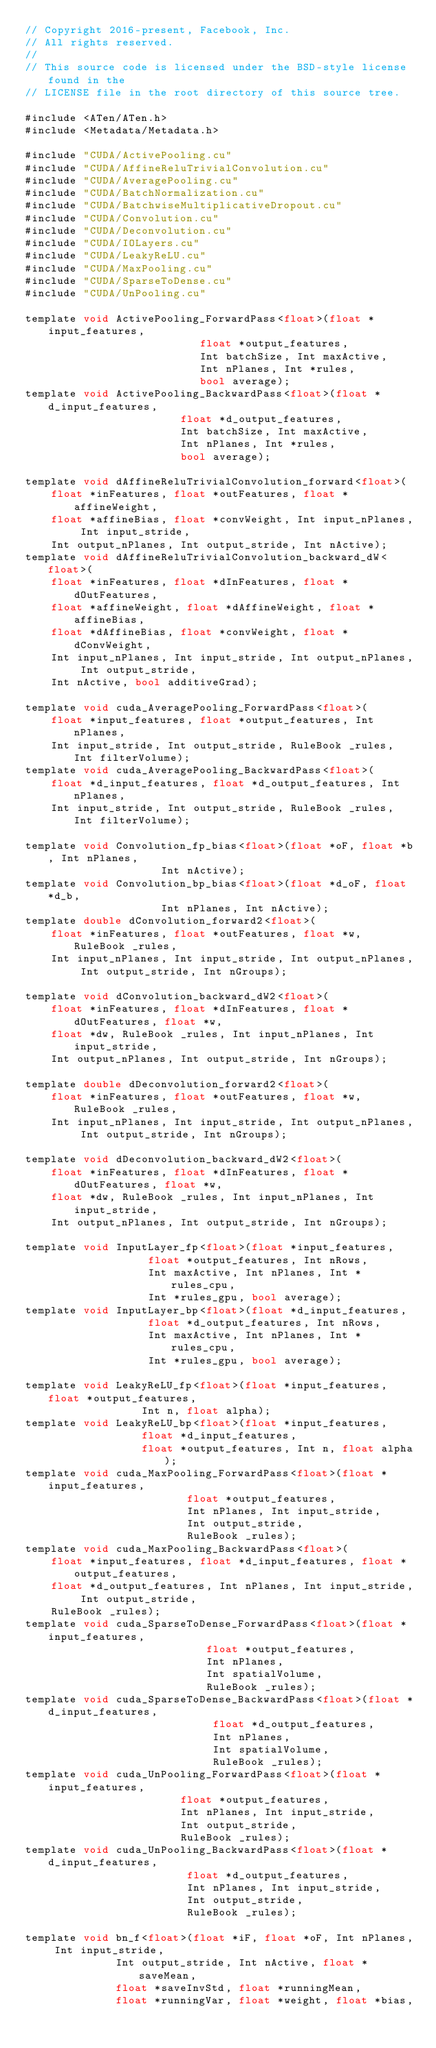Convert code to text. <code><loc_0><loc_0><loc_500><loc_500><_Cuda_>// Copyright 2016-present, Facebook, Inc.
// All rights reserved.
//
// This source code is licensed under the BSD-style license found in the
// LICENSE file in the root directory of this source tree.

#include <ATen/ATen.h>
#include <Metadata/Metadata.h>

#include "CUDA/ActivePooling.cu"
#include "CUDA/AffineReluTrivialConvolution.cu"
#include "CUDA/AveragePooling.cu"
#include "CUDA/BatchNormalization.cu"
#include "CUDA/BatchwiseMultiplicativeDropout.cu"
#include "CUDA/Convolution.cu"
#include "CUDA/Deconvolution.cu"
#include "CUDA/IOLayers.cu"
#include "CUDA/LeakyReLU.cu"
#include "CUDA/MaxPooling.cu"
#include "CUDA/SparseToDense.cu"
#include "CUDA/UnPooling.cu"

template void ActivePooling_ForwardPass<float>(float *input_features,
					       float *output_features,
					       Int batchSize, Int maxActive,
					       Int nPlanes, Int *rules,
					       bool average);
template void ActivePooling_BackwardPass<float>(float *d_input_features,
						float *d_output_features,
						Int batchSize, Int maxActive,
						Int nPlanes, Int *rules,
						bool average);

template void dAffineReluTrivialConvolution_forward<float>(
    float *inFeatures, float *outFeatures, float *affineWeight,
    float *affineBias, float *convWeight, Int input_nPlanes, Int input_stride,
    Int output_nPlanes, Int output_stride, Int nActive);
template void dAffineReluTrivialConvolution_backward_dW<float>(
    float *inFeatures, float *dInFeatures, float *dOutFeatures,
    float *affineWeight, float *dAffineWeight, float *affineBias,
    float *dAffineBias, float *convWeight, float *dConvWeight,
    Int input_nPlanes, Int input_stride, Int output_nPlanes, Int output_stride,
    Int nActive, bool additiveGrad);

template void cuda_AveragePooling_ForwardPass<float>(
    float *input_features, float *output_features, Int nPlanes,
    Int input_stride, Int output_stride, RuleBook _rules, Int filterVolume);
template void cuda_AveragePooling_BackwardPass<float>(
    float *d_input_features, float *d_output_features, Int nPlanes,
    Int input_stride, Int output_stride, RuleBook _rules, Int filterVolume);

template void Convolution_fp_bias<float>(float *oF, float *b, Int nPlanes,
					 Int nActive);
template void Convolution_bp_bias<float>(float *d_oF, float *d_b,
					 Int nPlanes, Int nActive);
template double dConvolution_forward2<float>(
    float *inFeatures, float *outFeatures, float *w, RuleBook _rules,
    Int input_nPlanes, Int input_stride, Int output_nPlanes, Int output_stride, Int nGroups);

template void dConvolution_backward_dW2<float>(
    float *inFeatures, float *dInFeatures, float *dOutFeatures, float *w,
    float *dw, RuleBook _rules, Int input_nPlanes, Int input_stride,
    Int output_nPlanes, Int output_stride, Int nGroups);

template double dDeconvolution_forward2<float>(
    float *inFeatures, float *outFeatures, float *w, RuleBook _rules,
    Int input_nPlanes, Int input_stride, Int output_nPlanes, Int output_stride, Int nGroups);

template void dDeconvolution_backward_dW2<float>(
    float *inFeatures, float *dInFeatures, float *dOutFeatures, float *w,
    float *dw, RuleBook _rules, Int input_nPlanes, Int input_stride,
    Int output_nPlanes, Int output_stride, Int nGroups);

template void InputLayer_fp<float>(float *input_features,
				   float *output_features, Int nRows,
				   Int maxActive, Int nPlanes, Int *rules_cpu,
				   Int *rules_gpu, bool average);
template void InputLayer_bp<float>(float *d_input_features,
				   float *d_output_features, Int nRows,
				   Int maxActive, Int nPlanes, Int *rules_cpu,
				   Int *rules_gpu, bool average);

template void LeakyReLU_fp<float>(float *input_features, float *output_features,
				  Int n, float alpha);
template void LeakyReLU_bp<float>(float *input_features,
				  float *d_input_features,
				  float *output_features, Int n, float alpha);
template void cuda_MaxPooling_ForwardPass<float>(float *input_features,
						 float *output_features,
						 Int nPlanes, Int input_stride,
						 Int output_stride,
						 RuleBook _rules);
template void cuda_MaxPooling_BackwardPass<float>(
    float *input_features, float *d_input_features, float *output_features,
    float *d_output_features, Int nPlanes, Int input_stride, Int output_stride,
    RuleBook _rules);
template void cuda_SparseToDense_ForwardPass<float>(float *input_features,
						    float *output_features,
						    Int nPlanes,
						    Int spatialVolume,
						    RuleBook _rules);
template void cuda_SparseToDense_BackwardPass<float>(float *d_input_features,
						     float *d_output_features,
						     Int nPlanes,
						     Int spatialVolume,
						     RuleBook _rules);
template void cuda_UnPooling_ForwardPass<float>(float *input_features,
						float *output_features,
						Int nPlanes, Int input_stride,
						Int output_stride,
						RuleBook _rules);
template void cuda_UnPooling_BackwardPass<float>(float *d_input_features,
						 float *d_output_features,
						 Int nPlanes, Int input_stride,
						 Int output_stride,
						 RuleBook _rules);

template void bn_f<float>(float *iF, float *oF, Int nPlanes, Int input_stride,
			  Int output_stride, Int nActive, float *saveMean,
			  float *saveInvStd, float *runningMean,
			  float *runningVar, float *weight, float *bias,</code> 